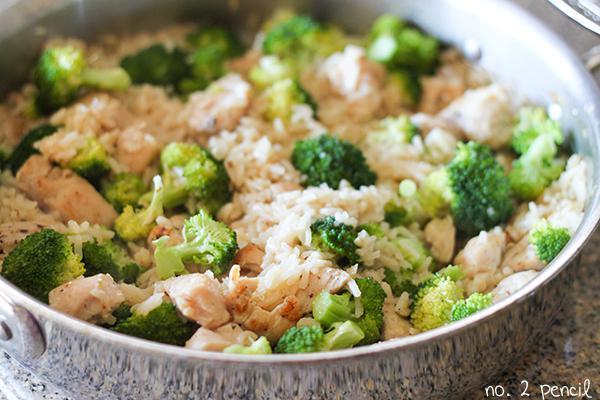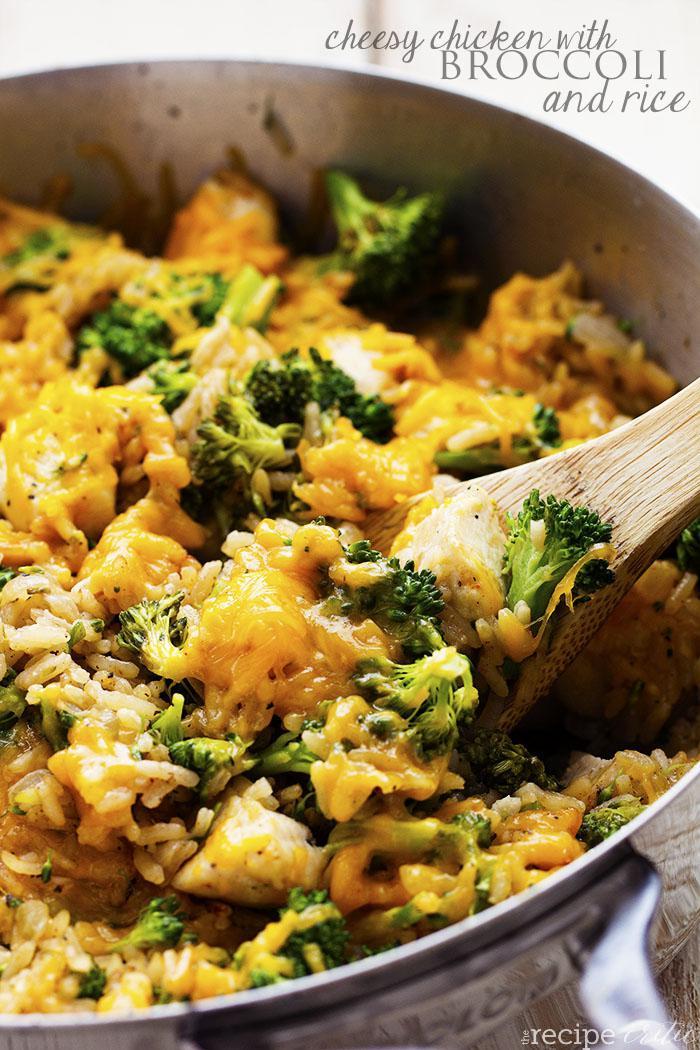The first image is the image on the left, the second image is the image on the right. Evaluate the accuracy of this statement regarding the images: "There is a fork on one of the images.". Is it true? Answer yes or no. No. 